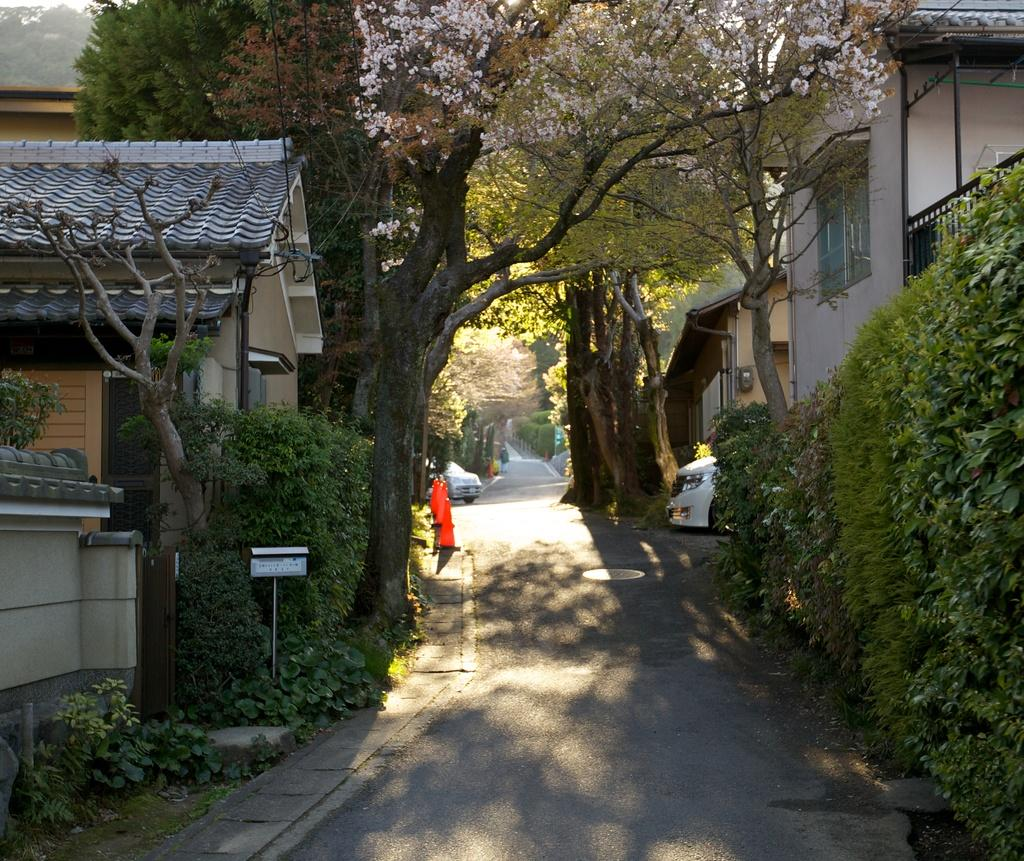What type of vehicles can be seen in the image? There are cars in the image. What natural elements are present in the image? There are trees and plants in the image. What type of structures can be seen in the image? There are houses in the image. What is the main pathway in the image? There is a road in the image. Can you describe an object on the left side of the image? There is a box on the left side of the image. What other object is on the left side of the image? There is a pole on the left side of the image. How many mice are hiding under the stove in the image? There is no stove or mice present in the image. What type of part is missing from the car in the image? There is no indication of a missing part from the cars in the image. 